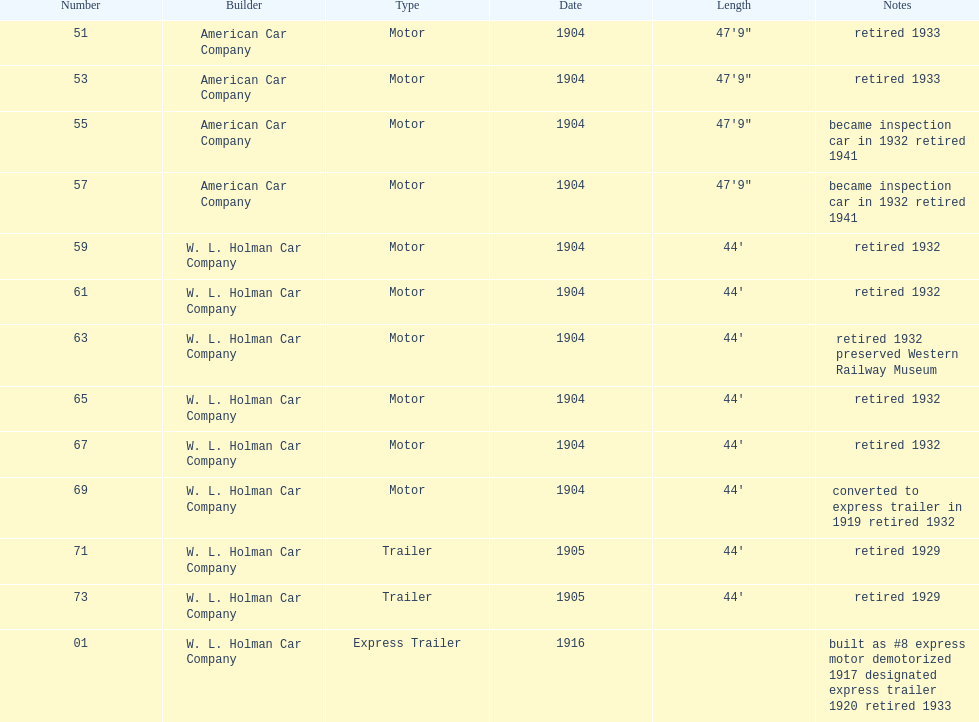What was the number of cars built by american car company? 4. 